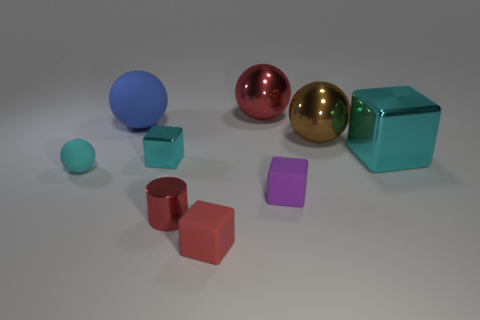Subtract all spheres. How many objects are left? 5 Subtract all tiny red spheres. Subtract all tiny shiny cubes. How many objects are left? 8 Add 5 purple matte objects. How many purple matte objects are left? 6 Add 4 large metal things. How many large metal things exist? 7 Subtract 1 red cylinders. How many objects are left? 8 